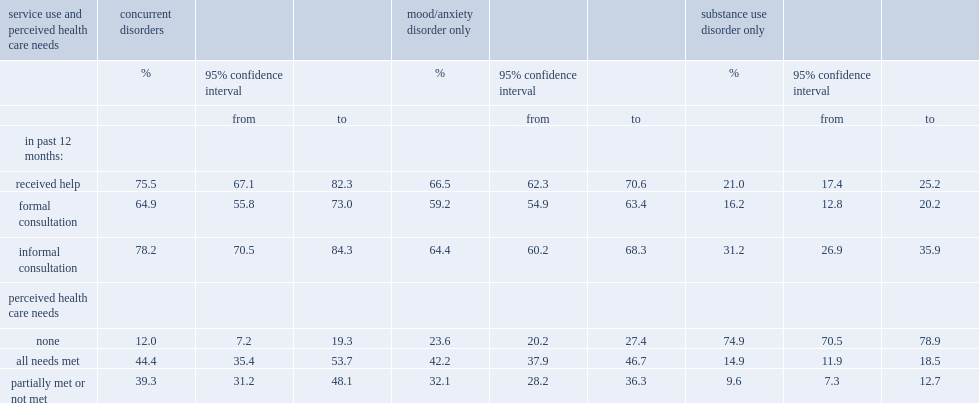Who is more likely to have received help for their emotions, mental health or substance use in the past 12 months,people with concurrent disorders or those with a mood/anxiety disorder? Concurrent disorders. Who is more likely to have received help for their emotions, mental health or substance use in the past 12 months,people with concurrent disorders or those with substance use disorder? Concurrent disorders. 